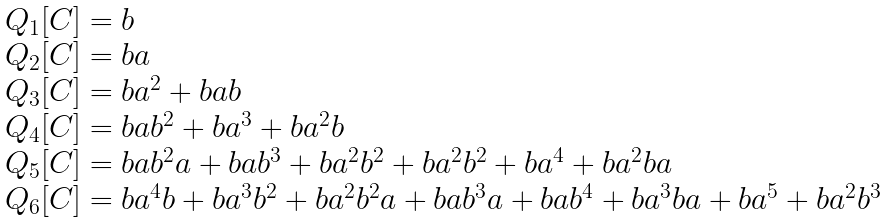<formula> <loc_0><loc_0><loc_500><loc_500>\begin{array} { l } Q _ { 1 } [ C ] = b \\ Q _ { 2 } [ C ] = b a \\ Q _ { 3 } [ C ] = b a ^ { 2 } + b a b \\ Q _ { 4 } [ C ] = b a b ^ { 2 } + b a ^ { 3 } + b a ^ { 2 } b \\ Q _ { 5 } [ C ] = b a b ^ { 2 } a + b a b ^ { 3 } + b a ^ { 2 } b ^ { 2 } + b a ^ { 2 } b ^ { 2 } + b a ^ { 4 } + b a ^ { 2 } b a \\ Q _ { 6 } [ C ] = b a ^ { 4 } b + b a ^ { 3 } b ^ { 2 } + b a ^ { 2 } b ^ { 2 } a + b a b ^ { 3 } a + b a b ^ { 4 } + b a ^ { 3 } b a + b a ^ { 5 } + b a ^ { 2 } b ^ { 3 } \end{array}</formula> 